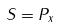<formula> <loc_0><loc_0><loc_500><loc_500>S = P _ { x }</formula> 